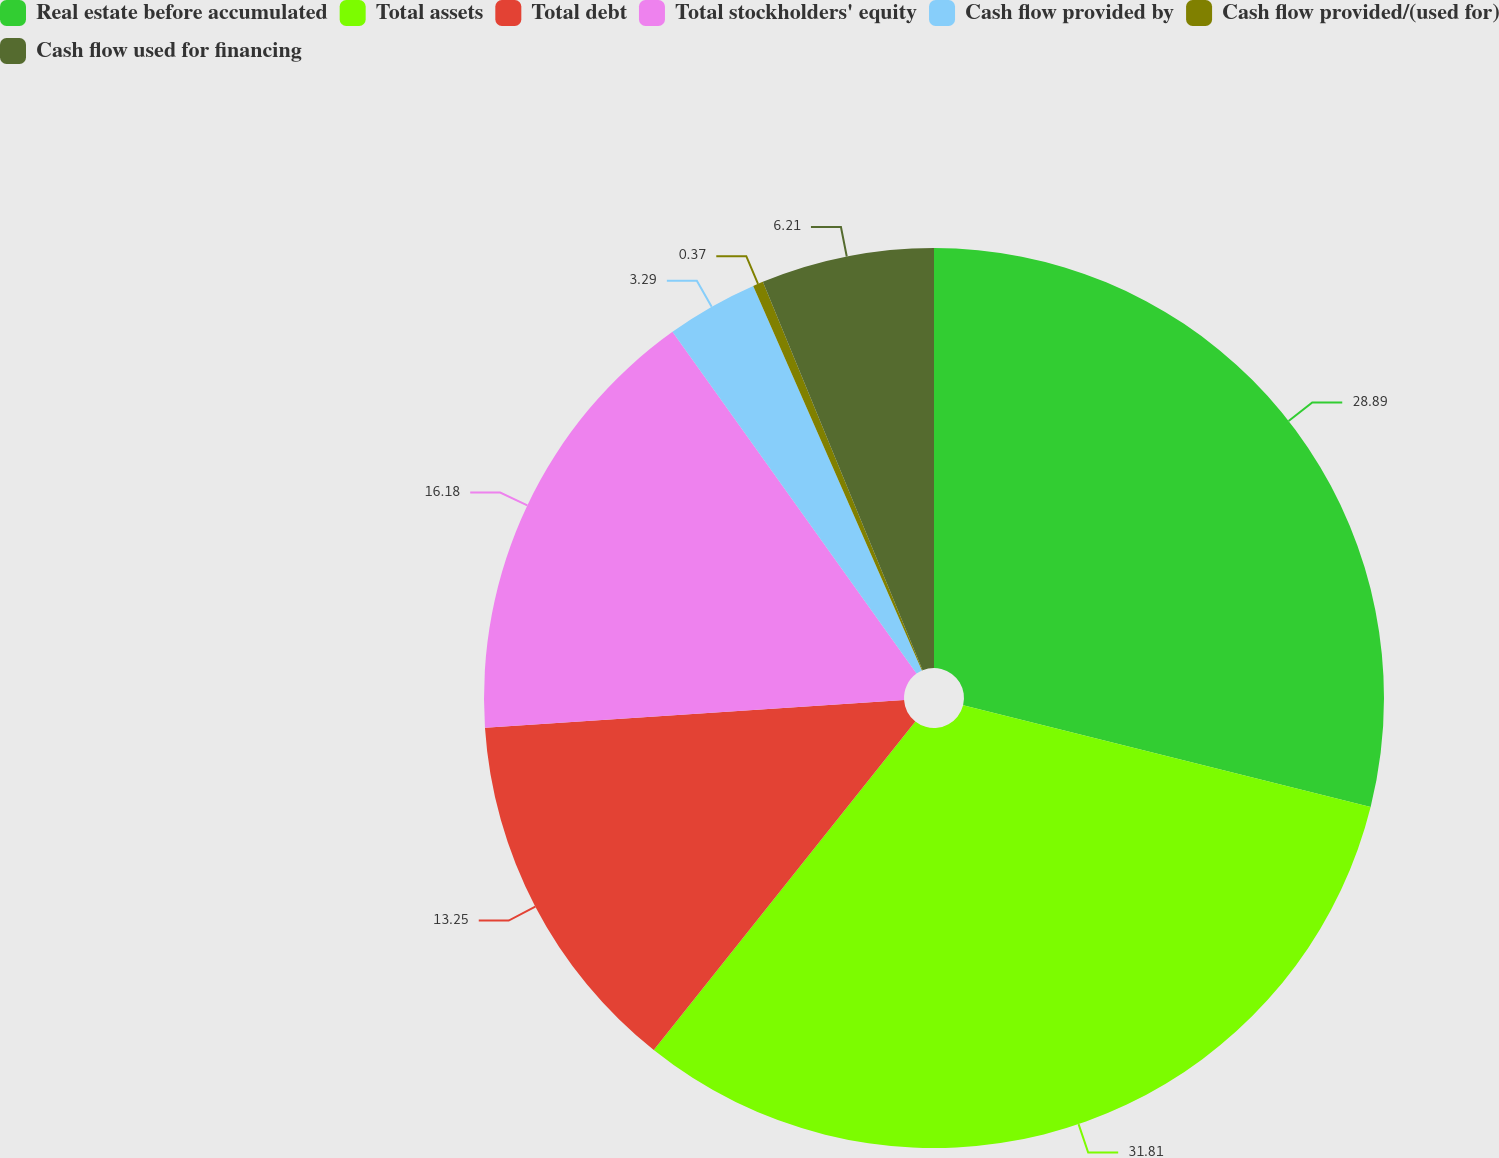<chart> <loc_0><loc_0><loc_500><loc_500><pie_chart><fcel>Real estate before accumulated<fcel>Total assets<fcel>Total debt<fcel>Total stockholders' equity<fcel>Cash flow provided by<fcel>Cash flow provided/(used for)<fcel>Cash flow used for financing<nl><fcel>28.89%<fcel>31.81%<fcel>13.25%<fcel>16.18%<fcel>3.29%<fcel>0.37%<fcel>6.21%<nl></chart> 